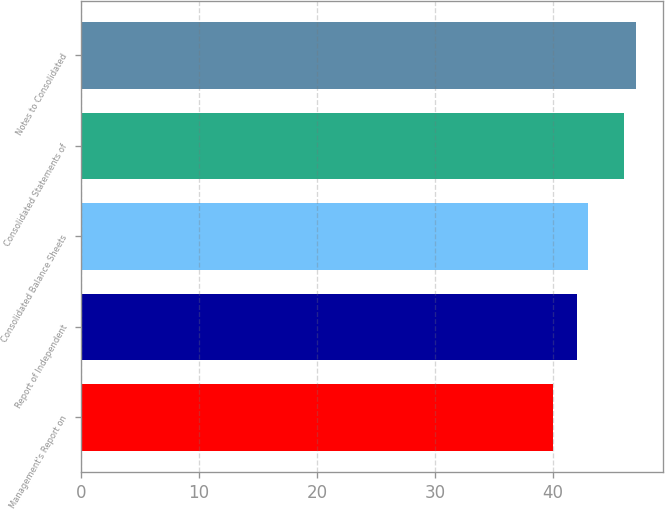<chart> <loc_0><loc_0><loc_500><loc_500><bar_chart><fcel>Management's Report on<fcel>Report of Independent<fcel>Consolidated Balance Sheets<fcel>Consolidated Statements of<fcel>Notes to Consolidated<nl><fcel>40<fcel>42<fcel>43<fcel>46<fcel>47<nl></chart> 